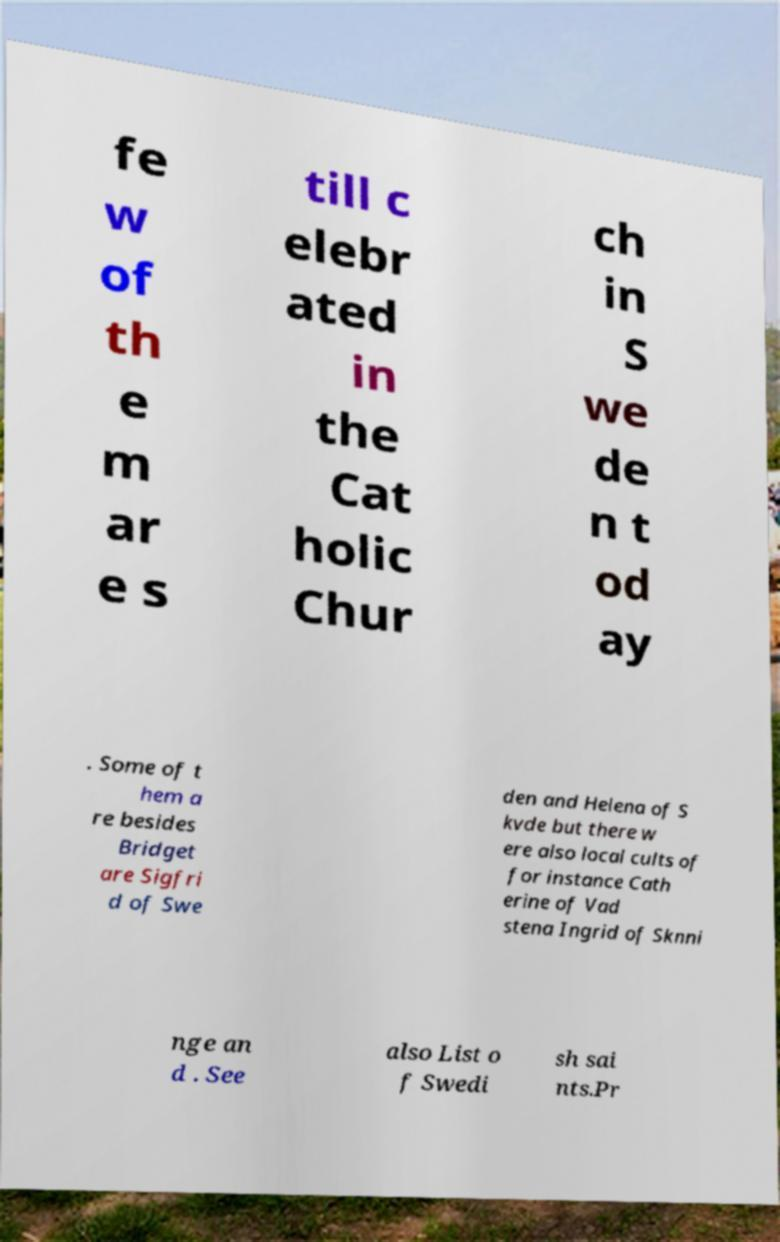Please read and relay the text visible in this image. What does it say? fe w of th e m ar e s till c elebr ated in the Cat holic Chur ch in S we de n t od ay . Some of t hem a re besides Bridget are Sigfri d of Swe den and Helena of S kvde but there w ere also local cults of for instance Cath erine of Vad stena Ingrid of Sknni nge an d . See also List o f Swedi sh sai nts.Pr 